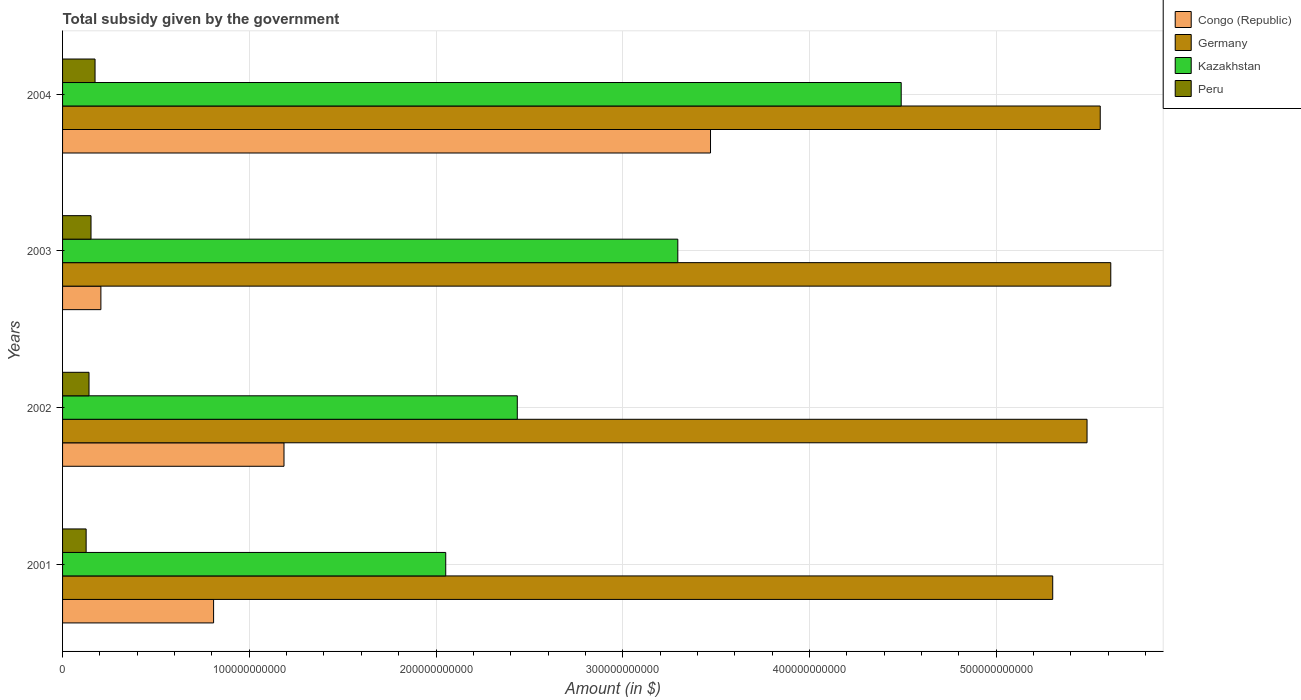How many different coloured bars are there?
Your answer should be compact. 4. Are the number of bars per tick equal to the number of legend labels?
Your answer should be very brief. Yes. How many bars are there on the 3rd tick from the top?
Give a very brief answer. 4. How many bars are there on the 4th tick from the bottom?
Give a very brief answer. 4. What is the label of the 4th group of bars from the top?
Keep it short and to the point. 2001. What is the total revenue collected by the government in Congo (Republic) in 2001?
Give a very brief answer. 8.09e+1. Across all years, what is the maximum total revenue collected by the government in Congo (Republic)?
Ensure brevity in your answer.  3.47e+11. Across all years, what is the minimum total revenue collected by the government in Peru?
Your response must be concise. 1.26e+1. What is the total total revenue collected by the government in Kazakhstan in the graph?
Keep it short and to the point. 1.23e+12. What is the difference between the total revenue collected by the government in Congo (Republic) in 2002 and that in 2004?
Give a very brief answer. -2.28e+11. What is the difference between the total revenue collected by the government in Peru in 2001 and the total revenue collected by the government in Congo (Republic) in 2002?
Make the answer very short. -1.06e+11. What is the average total revenue collected by the government in Congo (Republic) per year?
Make the answer very short. 1.42e+11. In the year 2002, what is the difference between the total revenue collected by the government in Peru and total revenue collected by the government in Congo (Republic)?
Keep it short and to the point. -1.04e+11. In how many years, is the total revenue collected by the government in Kazakhstan greater than 140000000000 $?
Offer a very short reply. 4. What is the ratio of the total revenue collected by the government in Peru in 2003 to that in 2004?
Offer a very short reply. 0.88. What is the difference between the highest and the second highest total revenue collected by the government in Kazakhstan?
Ensure brevity in your answer.  1.20e+11. What is the difference between the highest and the lowest total revenue collected by the government in Congo (Republic)?
Offer a very short reply. 3.26e+11. Is the sum of the total revenue collected by the government in Congo (Republic) in 2001 and 2004 greater than the maximum total revenue collected by the government in Germany across all years?
Offer a terse response. No. Is it the case that in every year, the sum of the total revenue collected by the government in Kazakhstan and total revenue collected by the government in Congo (Republic) is greater than the sum of total revenue collected by the government in Peru and total revenue collected by the government in Germany?
Your answer should be very brief. Yes. What does the 1st bar from the bottom in 2001 represents?
Offer a terse response. Congo (Republic). Is it the case that in every year, the sum of the total revenue collected by the government in Peru and total revenue collected by the government in Germany is greater than the total revenue collected by the government in Congo (Republic)?
Keep it short and to the point. Yes. Are all the bars in the graph horizontal?
Give a very brief answer. Yes. How many years are there in the graph?
Provide a short and direct response. 4. What is the difference between two consecutive major ticks on the X-axis?
Your response must be concise. 1.00e+11. How many legend labels are there?
Ensure brevity in your answer.  4. How are the legend labels stacked?
Provide a short and direct response. Vertical. What is the title of the graph?
Your answer should be compact. Total subsidy given by the government. Does "Cabo Verde" appear as one of the legend labels in the graph?
Offer a very short reply. No. What is the label or title of the X-axis?
Ensure brevity in your answer.  Amount (in $). What is the label or title of the Y-axis?
Your answer should be compact. Years. What is the Amount (in $) of Congo (Republic) in 2001?
Ensure brevity in your answer.  8.09e+1. What is the Amount (in $) of Germany in 2001?
Provide a short and direct response. 5.30e+11. What is the Amount (in $) in Kazakhstan in 2001?
Your answer should be very brief. 2.05e+11. What is the Amount (in $) of Peru in 2001?
Make the answer very short. 1.26e+1. What is the Amount (in $) in Congo (Republic) in 2002?
Offer a very short reply. 1.19e+11. What is the Amount (in $) of Germany in 2002?
Your answer should be compact. 5.49e+11. What is the Amount (in $) of Kazakhstan in 2002?
Provide a succinct answer. 2.44e+11. What is the Amount (in $) in Peru in 2002?
Give a very brief answer. 1.42e+1. What is the Amount (in $) of Congo (Republic) in 2003?
Offer a very short reply. 2.05e+1. What is the Amount (in $) of Germany in 2003?
Offer a very short reply. 5.61e+11. What is the Amount (in $) of Kazakhstan in 2003?
Offer a very short reply. 3.29e+11. What is the Amount (in $) in Peru in 2003?
Offer a very short reply. 1.52e+1. What is the Amount (in $) in Congo (Republic) in 2004?
Your response must be concise. 3.47e+11. What is the Amount (in $) of Germany in 2004?
Ensure brevity in your answer.  5.56e+11. What is the Amount (in $) in Kazakhstan in 2004?
Make the answer very short. 4.49e+11. What is the Amount (in $) in Peru in 2004?
Make the answer very short. 1.74e+1. Across all years, what is the maximum Amount (in $) of Congo (Republic)?
Your answer should be compact. 3.47e+11. Across all years, what is the maximum Amount (in $) in Germany?
Ensure brevity in your answer.  5.61e+11. Across all years, what is the maximum Amount (in $) of Kazakhstan?
Make the answer very short. 4.49e+11. Across all years, what is the maximum Amount (in $) of Peru?
Keep it short and to the point. 1.74e+1. Across all years, what is the minimum Amount (in $) of Congo (Republic)?
Keep it short and to the point. 2.05e+1. Across all years, what is the minimum Amount (in $) in Germany?
Provide a succinct answer. 5.30e+11. Across all years, what is the minimum Amount (in $) of Kazakhstan?
Give a very brief answer. 2.05e+11. Across all years, what is the minimum Amount (in $) of Peru?
Offer a very short reply. 1.26e+1. What is the total Amount (in $) of Congo (Republic) in the graph?
Give a very brief answer. 5.67e+11. What is the total Amount (in $) of Germany in the graph?
Provide a short and direct response. 2.20e+12. What is the total Amount (in $) in Kazakhstan in the graph?
Your answer should be compact. 1.23e+12. What is the total Amount (in $) in Peru in the graph?
Make the answer very short. 5.94e+1. What is the difference between the Amount (in $) of Congo (Republic) in 2001 and that in 2002?
Provide a succinct answer. -3.77e+1. What is the difference between the Amount (in $) in Germany in 2001 and that in 2002?
Your answer should be very brief. -1.84e+1. What is the difference between the Amount (in $) in Kazakhstan in 2001 and that in 2002?
Offer a terse response. -3.83e+1. What is the difference between the Amount (in $) in Peru in 2001 and that in 2002?
Provide a short and direct response. -1.55e+09. What is the difference between the Amount (in $) of Congo (Republic) in 2001 and that in 2003?
Your response must be concise. 6.04e+1. What is the difference between the Amount (in $) of Germany in 2001 and that in 2003?
Give a very brief answer. -3.11e+1. What is the difference between the Amount (in $) in Kazakhstan in 2001 and that in 2003?
Make the answer very short. -1.24e+11. What is the difference between the Amount (in $) of Peru in 2001 and that in 2003?
Your response must be concise. -2.62e+09. What is the difference between the Amount (in $) in Congo (Republic) in 2001 and that in 2004?
Ensure brevity in your answer.  -2.66e+11. What is the difference between the Amount (in $) of Germany in 2001 and that in 2004?
Keep it short and to the point. -2.54e+1. What is the difference between the Amount (in $) in Kazakhstan in 2001 and that in 2004?
Offer a terse response. -2.44e+11. What is the difference between the Amount (in $) in Peru in 2001 and that in 2004?
Your response must be concise. -4.78e+09. What is the difference between the Amount (in $) of Congo (Republic) in 2002 and that in 2003?
Keep it short and to the point. 9.81e+1. What is the difference between the Amount (in $) in Germany in 2002 and that in 2003?
Provide a short and direct response. -1.27e+1. What is the difference between the Amount (in $) of Kazakhstan in 2002 and that in 2003?
Offer a very short reply. -8.60e+1. What is the difference between the Amount (in $) of Peru in 2002 and that in 2003?
Offer a very short reply. -1.07e+09. What is the difference between the Amount (in $) in Congo (Republic) in 2002 and that in 2004?
Your response must be concise. -2.28e+11. What is the difference between the Amount (in $) in Germany in 2002 and that in 2004?
Keep it short and to the point. -7.06e+09. What is the difference between the Amount (in $) of Kazakhstan in 2002 and that in 2004?
Your answer should be very brief. -2.06e+11. What is the difference between the Amount (in $) in Peru in 2002 and that in 2004?
Keep it short and to the point. -3.23e+09. What is the difference between the Amount (in $) of Congo (Republic) in 2003 and that in 2004?
Ensure brevity in your answer.  -3.26e+11. What is the difference between the Amount (in $) in Germany in 2003 and that in 2004?
Provide a succinct answer. 5.65e+09. What is the difference between the Amount (in $) of Kazakhstan in 2003 and that in 2004?
Offer a very short reply. -1.20e+11. What is the difference between the Amount (in $) in Peru in 2003 and that in 2004?
Keep it short and to the point. -2.16e+09. What is the difference between the Amount (in $) in Congo (Republic) in 2001 and the Amount (in $) in Germany in 2002?
Provide a short and direct response. -4.68e+11. What is the difference between the Amount (in $) in Congo (Republic) in 2001 and the Amount (in $) in Kazakhstan in 2002?
Offer a terse response. -1.63e+11. What is the difference between the Amount (in $) of Congo (Republic) in 2001 and the Amount (in $) of Peru in 2002?
Keep it short and to the point. 6.67e+1. What is the difference between the Amount (in $) of Germany in 2001 and the Amount (in $) of Kazakhstan in 2002?
Make the answer very short. 2.87e+11. What is the difference between the Amount (in $) of Germany in 2001 and the Amount (in $) of Peru in 2002?
Offer a terse response. 5.16e+11. What is the difference between the Amount (in $) of Kazakhstan in 2001 and the Amount (in $) of Peru in 2002?
Your answer should be compact. 1.91e+11. What is the difference between the Amount (in $) in Congo (Republic) in 2001 and the Amount (in $) in Germany in 2003?
Offer a very short reply. -4.80e+11. What is the difference between the Amount (in $) of Congo (Republic) in 2001 and the Amount (in $) of Kazakhstan in 2003?
Your response must be concise. -2.49e+11. What is the difference between the Amount (in $) in Congo (Republic) in 2001 and the Amount (in $) in Peru in 2003?
Your answer should be compact. 6.56e+1. What is the difference between the Amount (in $) in Germany in 2001 and the Amount (in $) in Kazakhstan in 2003?
Provide a short and direct response. 2.01e+11. What is the difference between the Amount (in $) of Germany in 2001 and the Amount (in $) of Peru in 2003?
Ensure brevity in your answer.  5.15e+11. What is the difference between the Amount (in $) of Kazakhstan in 2001 and the Amount (in $) of Peru in 2003?
Your answer should be compact. 1.90e+11. What is the difference between the Amount (in $) of Congo (Republic) in 2001 and the Amount (in $) of Germany in 2004?
Ensure brevity in your answer.  -4.75e+11. What is the difference between the Amount (in $) of Congo (Republic) in 2001 and the Amount (in $) of Kazakhstan in 2004?
Your answer should be very brief. -3.68e+11. What is the difference between the Amount (in $) in Congo (Republic) in 2001 and the Amount (in $) in Peru in 2004?
Keep it short and to the point. 6.35e+1. What is the difference between the Amount (in $) in Germany in 2001 and the Amount (in $) in Kazakhstan in 2004?
Your answer should be compact. 8.11e+1. What is the difference between the Amount (in $) in Germany in 2001 and the Amount (in $) in Peru in 2004?
Your answer should be very brief. 5.13e+11. What is the difference between the Amount (in $) in Kazakhstan in 2001 and the Amount (in $) in Peru in 2004?
Offer a terse response. 1.88e+11. What is the difference between the Amount (in $) in Congo (Republic) in 2002 and the Amount (in $) in Germany in 2003?
Keep it short and to the point. -4.43e+11. What is the difference between the Amount (in $) in Congo (Republic) in 2002 and the Amount (in $) in Kazakhstan in 2003?
Your response must be concise. -2.11e+11. What is the difference between the Amount (in $) in Congo (Republic) in 2002 and the Amount (in $) in Peru in 2003?
Give a very brief answer. 1.03e+11. What is the difference between the Amount (in $) of Germany in 2002 and the Amount (in $) of Kazakhstan in 2003?
Provide a short and direct response. 2.19e+11. What is the difference between the Amount (in $) in Germany in 2002 and the Amount (in $) in Peru in 2003?
Offer a very short reply. 5.33e+11. What is the difference between the Amount (in $) in Kazakhstan in 2002 and the Amount (in $) in Peru in 2003?
Make the answer very short. 2.28e+11. What is the difference between the Amount (in $) of Congo (Republic) in 2002 and the Amount (in $) of Germany in 2004?
Ensure brevity in your answer.  -4.37e+11. What is the difference between the Amount (in $) in Congo (Republic) in 2002 and the Amount (in $) in Kazakhstan in 2004?
Provide a succinct answer. -3.31e+11. What is the difference between the Amount (in $) of Congo (Republic) in 2002 and the Amount (in $) of Peru in 2004?
Keep it short and to the point. 1.01e+11. What is the difference between the Amount (in $) of Germany in 2002 and the Amount (in $) of Kazakhstan in 2004?
Give a very brief answer. 9.95e+1. What is the difference between the Amount (in $) of Germany in 2002 and the Amount (in $) of Peru in 2004?
Your answer should be very brief. 5.31e+11. What is the difference between the Amount (in $) in Kazakhstan in 2002 and the Amount (in $) in Peru in 2004?
Keep it short and to the point. 2.26e+11. What is the difference between the Amount (in $) in Congo (Republic) in 2003 and the Amount (in $) in Germany in 2004?
Provide a short and direct response. -5.35e+11. What is the difference between the Amount (in $) in Congo (Republic) in 2003 and the Amount (in $) in Kazakhstan in 2004?
Ensure brevity in your answer.  -4.29e+11. What is the difference between the Amount (in $) in Congo (Republic) in 2003 and the Amount (in $) in Peru in 2004?
Make the answer very short. 3.13e+09. What is the difference between the Amount (in $) in Germany in 2003 and the Amount (in $) in Kazakhstan in 2004?
Offer a very short reply. 1.12e+11. What is the difference between the Amount (in $) of Germany in 2003 and the Amount (in $) of Peru in 2004?
Ensure brevity in your answer.  5.44e+11. What is the difference between the Amount (in $) of Kazakhstan in 2003 and the Amount (in $) of Peru in 2004?
Provide a short and direct response. 3.12e+11. What is the average Amount (in $) in Congo (Republic) per year?
Offer a terse response. 1.42e+11. What is the average Amount (in $) of Germany per year?
Provide a succinct answer. 5.49e+11. What is the average Amount (in $) in Kazakhstan per year?
Offer a terse response. 3.07e+11. What is the average Amount (in $) in Peru per year?
Offer a very short reply. 1.49e+1. In the year 2001, what is the difference between the Amount (in $) of Congo (Republic) and Amount (in $) of Germany?
Give a very brief answer. -4.49e+11. In the year 2001, what is the difference between the Amount (in $) of Congo (Republic) and Amount (in $) of Kazakhstan?
Ensure brevity in your answer.  -1.24e+11. In the year 2001, what is the difference between the Amount (in $) of Congo (Republic) and Amount (in $) of Peru?
Provide a succinct answer. 6.83e+1. In the year 2001, what is the difference between the Amount (in $) in Germany and Amount (in $) in Kazakhstan?
Give a very brief answer. 3.25e+11. In the year 2001, what is the difference between the Amount (in $) of Germany and Amount (in $) of Peru?
Your response must be concise. 5.18e+11. In the year 2001, what is the difference between the Amount (in $) in Kazakhstan and Amount (in $) in Peru?
Ensure brevity in your answer.  1.93e+11. In the year 2002, what is the difference between the Amount (in $) in Congo (Republic) and Amount (in $) in Germany?
Make the answer very short. -4.30e+11. In the year 2002, what is the difference between the Amount (in $) of Congo (Republic) and Amount (in $) of Kazakhstan?
Make the answer very short. -1.25e+11. In the year 2002, what is the difference between the Amount (in $) of Congo (Republic) and Amount (in $) of Peru?
Offer a terse response. 1.04e+11. In the year 2002, what is the difference between the Amount (in $) in Germany and Amount (in $) in Kazakhstan?
Keep it short and to the point. 3.05e+11. In the year 2002, what is the difference between the Amount (in $) in Germany and Amount (in $) in Peru?
Your answer should be compact. 5.35e+11. In the year 2002, what is the difference between the Amount (in $) of Kazakhstan and Amount (in $) of Peru?
Provide a short and direct response. 2.29e+11. In the year 2003, what is the difference between the Amount (in $) of Congo (Republic) and Amount (in $) of Germany?
Keep it short and to the point. -5.41e+11. In the year 2003, what is the difference between the Amount (in $) in Congo (Republic) and Amount (in $) in Kazakhstan?
Ensure brevity in your answer.  -3.09e+11. In the year 2003, what is the difference between the Amount (in $) in Congo (Republic) and Amount (in $) in Peru?
Give a very brief answer. 5.28e+09. In the year 2003, what is the difference between the Amount (in $) of Germany and Amount (in $) of Kazakhstan?
Your response must be concise. 2.32e+11. In the year 2003, what is the difference between the Amount (in $) of Germany and Amount (in $) of Peru?
Ensure brevity in your answer.  5.46e+11. In the year 2003, what is the difference between the Amount (in $) of Kazakhstan and Amount (in $) of Peru?
Give a very brief answer. 3.14e+11. In the year 2004, what is the difference between the Amount (in $) of Congo (Republic) and Amount (in $) of Germany?
Provide a short and direct response. -2.09e+11. In the year 2004, what is the difference between the Amount (in $) of Congo (Republic) and Amount (in $) of Kazakhstan?
Your answer should be very brief. -1.02e+11. In the year 2004, what is the difference between the Amount (in $) in Congo (Republic) and Amount (in $) in Peru?
Give a very brief answer. 3.30e+11. In the year 2004, what is the difference between the Amount (in $) of Germany and Amount (in $) of Kazakhstan?
Your answer should be compact. 1.07e+11. In the year 2004, what is the difference between the Amount (in $) in Germany and Amount (in $) in Peru?
Offer a very short reply. 5.38e+11. In the year 2004, what is the difference between the Amount (in $) of Kazakhstan and Amount (in $) of Peru?
Your answer should be very brief. 4.32e+11. What is the ratio of the Amount (in $) in Congo (Republic) in 2001 to that in 2002?
Provide a succinct answer. 0.68. What is the ratio of the Amount (in $) in Germany in 2001 to that in 2002?
Your answer should be very brief. 0.97. What is the ratio of the Amount (in $) in Kazakhstan in 2001 to that in 2002?
Keep it short and to the point. 0.84. What is the ratio of the Amount (in $) of Peru in 2001 to that in 2002?
Provide a succinct answer. 0.89. What is the ratio of the Amount (in $) in Congo (Republic) in 2001 to that in 2003?
Give a very brief answer. 3.94. What is the ratio of the Amount (in $) in Germany in 2001 to that in 2003?
Provide a short and direct response. 0.94. What is the ratio of the Amount (in $) in Kazakhstan in 2001 to that in 2003?
Make the answer very short. 0.62. What is the ratio of the Amount (in $) in Peru in 2001 to that in 2003?
Your response must be concise. 0.83. What is the ratio of the Amount (in $) of Congo (Republic) in 2001 to that in 2004?
Keep it short and to the point. 0.23. What is the ratio of the Amount (in $) in Germany in 2001 to that in 2004?
Offer a terse response. 0.95. What is the ratio of the Amount (in $) of Kazakhstan in 2001 to that in 2004?
Your answer should be very brief. 0.46. What is the ratio of the Amount (in $) of Peru in 2001 to that in 2004?
Provide a succinct answer. 0.73. What is the ratio of the Amount (in $) of Congo (Republic) in 2002 to that in 2003?
Offer a very short reply. 5.78. What is the ratio of the Amount (in $) of Germany in 2002 to that in 2003?
Your answer should be very brief. 0.98. What is the ratio of the Amount (in $) in Kazakhstan in 2002 to that in 2003?
Make the answer very short. 0.74. What is the ratio of the Amount (in $) in Peru in 2002 to that in 2003?
Make the answer very short. 0.93. What is the ratio of the Amount (in $) of Congo (Republic) in 2002 to that in 2004?
Ensure brevity in your answer.  0.34. What is the ratio of the Amount (in $) of Germany in 2002 to that in 2004?
Give a very brief answer. 0.99. What is the ratio of the Amount (in $) of Kazakhstan in 2002 to that in 2004?
Give a very brief answer. 0.54. What is the ratio of the Amount (in $) of Peru in 2002 to that in 2004?
Your response must be concise. 0.81. What is the ratio of the Amount (in $) in Congo (Republic) in 2003 to that in 2004?
Your answer should be very brief. 0.06. What is the ratio of the Amount (in $) of Germany in 2003 to that in 2004?
Your answer should be very brief. 1.01. What is the ratio of the Amount (in $) in Kazakhstan in 2003 to that in 2004?
Your answer should be compact. 0.73. What is the ratio of the Amount (in $) of Peru in 2003 to that in 2004?
Give a very brief answer. 0.88. What is the difference between the highest and the second highest Amount (in $) of Congo (Republic)?
Your response must be concise. 2.28e+11. What is the difference between the highest and the second highest Amount (in $) of Germany?
Offer a very short reply. 5.65e+09. What is the difference between the highest and the second highest Amount (in $) of Kazakhstan?
Provide a succinct answer. 1.20e+11. What is the difference between the highest and the second highest Amount (in $) of Peru?
Offer a terse response. 2.16e+09. What is the difference between the highest and the lowest Amount (in $) in Congo (Republic)?
Give a very brief answer. 3.26e+11. What is the difference between the highest and the lowest Amount (in $) in Germany?
Your response must be concise. 3.11e+1. What is the difference between the highest and the lowest Amount (in $) in Kazakhstan?
Offer a terse response. 2.44e+11. What is the difference between the highest and the lowest Amount (in $) in Peru?
Make the answer very short. 4.78e+09. 